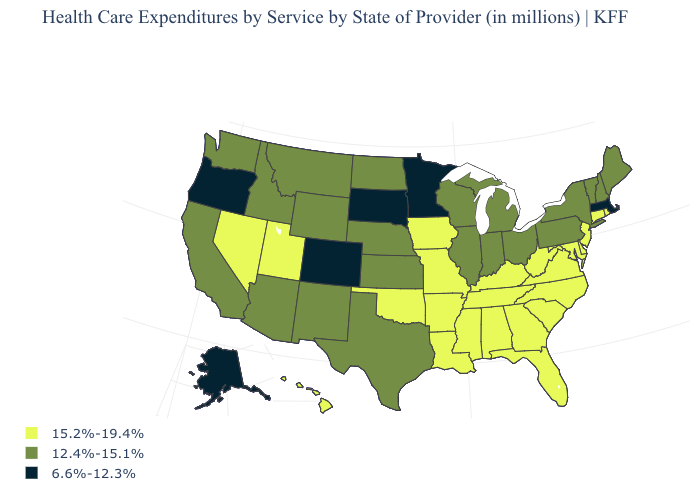What is the value of Massachusetts?
Keep it brief. 6.6%-12.3%. What is the value of Illinois?
Keep it brief. 12.4%-15.1%. What is the value of Iowa?
Concise answer only. 15.2%-19.4%. How many symbols are there in the legend?
Answer briefly. 3. Among the states that border California , which have the lowest value?
Give a very brief answer. Oregon. Name the states that have a value in the range 12.4%-15.1%?
Keep it brief. Arizona, California, Idaho, Illinois, Indiana, Kansas, Maine, Michigan, Montana, Nebraska, New Hampshire, New Mexico, New York, North Dakota, Ohio, Pennsylvania, Texas, Vermont, Washington, Wisconsin, Wyoming. Does the first symbol in the legend represent the smallest category?
Keep it brief. No. What is the highest value in states that border Washington?
Give a very brief answer. 12.4%-15.1%. Which states have the highest value in the USA?
Write a very short answer. Alabama, Arkansas, Connecticut, Delaware, Florida, Georgia, Hawaii, Iowa, Kentucky, Louisiana, Maryland, Mississippi, Missouri, Nevada, New Jersey, North Carolina, Oklahoma, Rhode Island, South Carolina, Tennessee, Utah, Virginia, West Virginia. What is the value of Florida?
Short answer required. 15.2%-19.4%. Which states hav the highest value in the Northeast?
Keep it brief. Connecticut, New Jersey, Rhode Island. What is the value of Texas?
Keep it brief. 12.4%-15.1%. Name the states that have a value in the range 15.2%-19.4%?
Concise answer only. Alabama, Arkansas, Connecticut, Delaware, Florida, Georgia, Hawaii, Iowa, Kentucky, Louisiana, Maryland, Mississippi, Missouri, Nevada, New Jersey, North Carolina, Oklahoma, Rhode Island, South Carolina, Tennessee, Utah, Virginia, West Virginia. Does Delaware have a higher value than Washington?
Quick response, please. Yes. What is the lowest value in states that border Michigan?
Keep it brief. 12.4%-15.1%. 